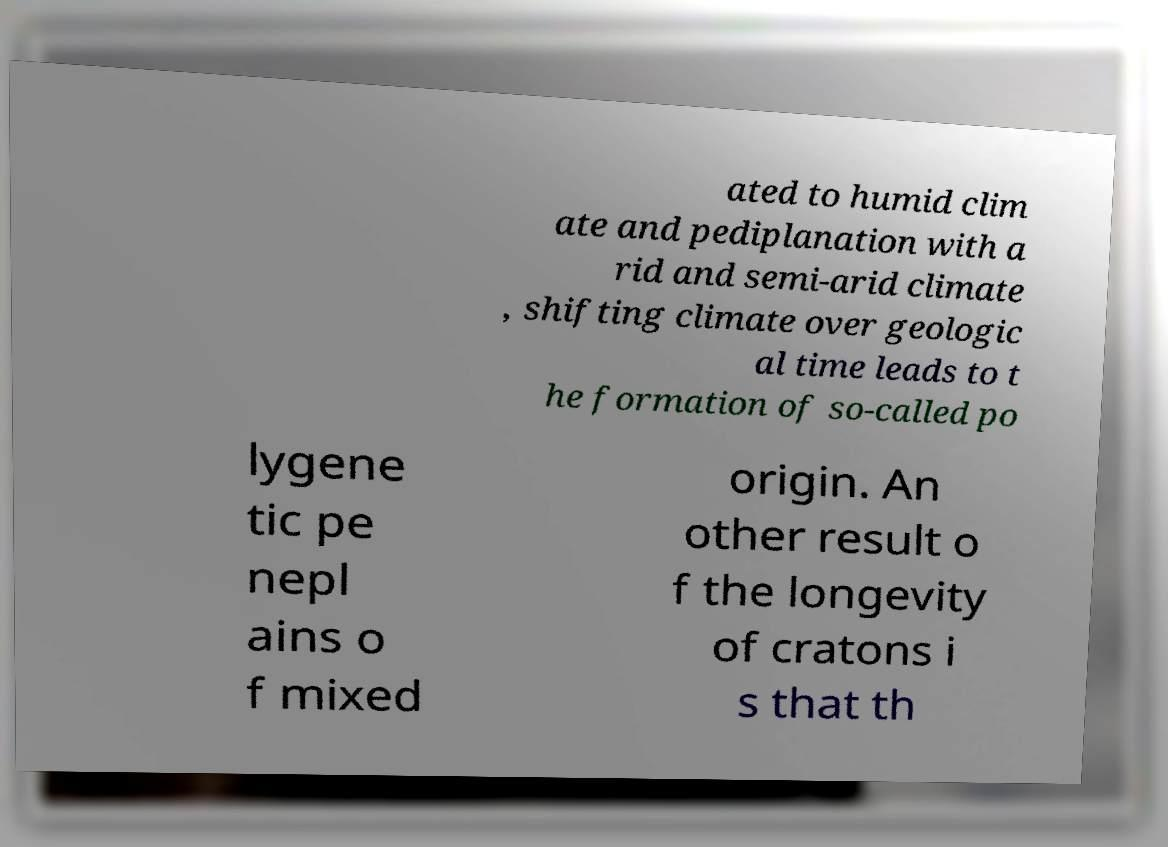Please read and relay the text visible in this image. What does it say? ated to humid clim ate and pediplanation with a rid and semi-arid climate , shifting climate over geologic al time leads to t he formation of so-called po lygene tic pe nepl ains o f mixed origin. An other result o f the longevity of cratons i s that th 